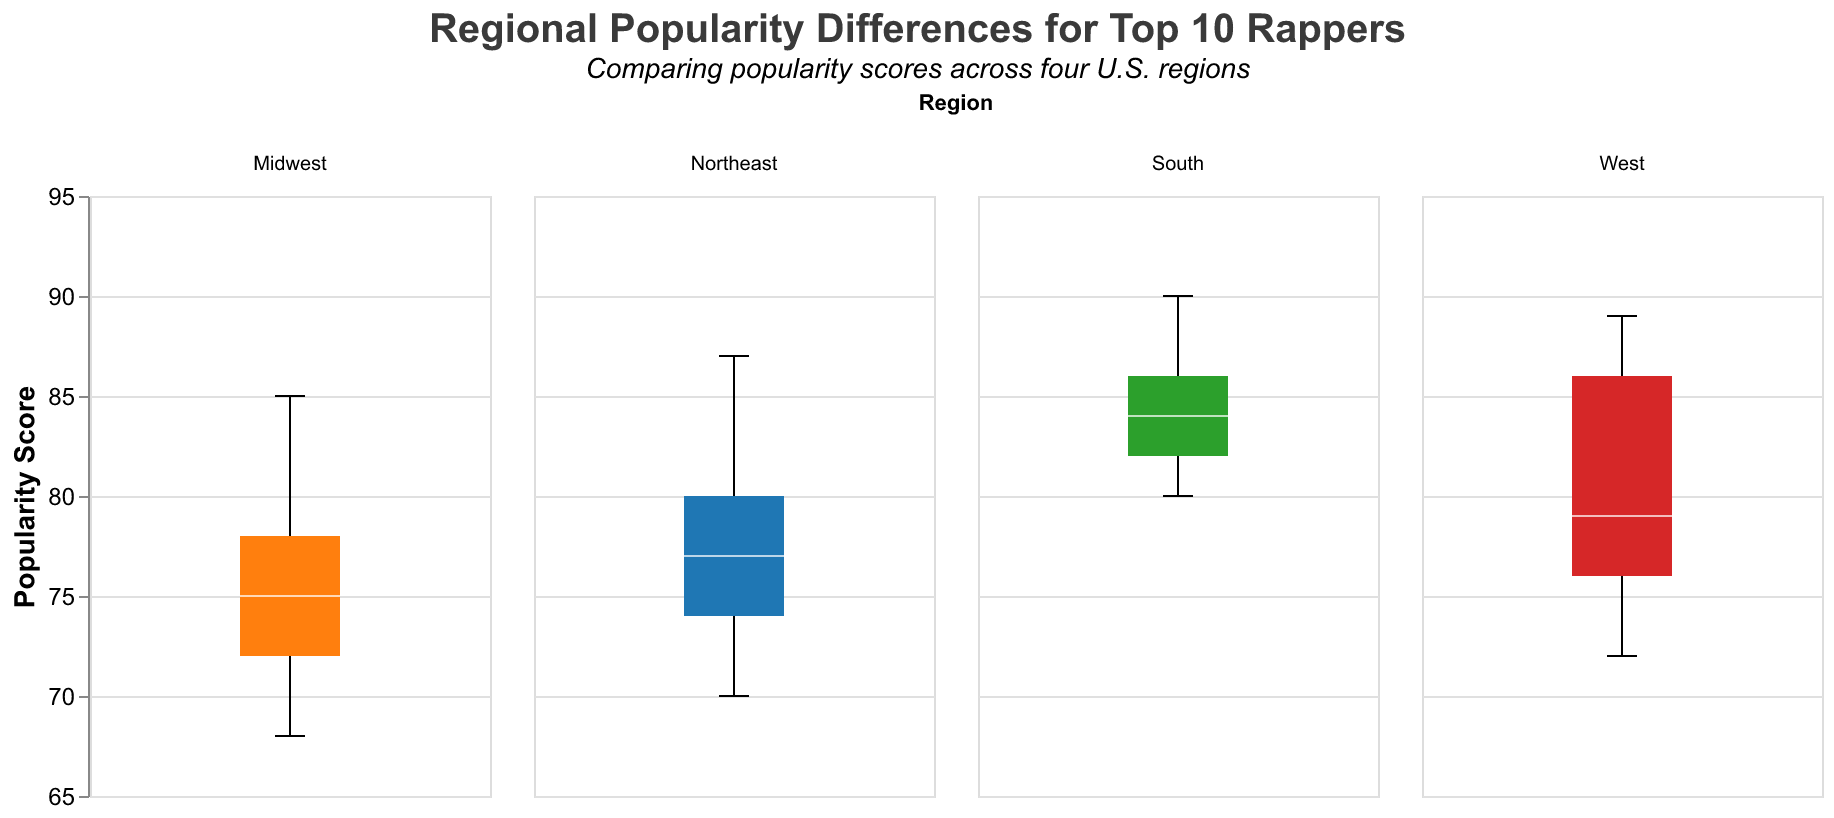How many regions are shown in the figure? The figure has separate subplots for each region. Observing the columns, there are four distinct regions displayed.
Answer: 4 Who is the most popular rapper in the South region? By examining the maximum values in the South region subplot, Drake has the highest popularity score of 90.
Answer: Drake Which rapper has the lowest popularity in the Midwest region? By looking at the minimum values in the Midwest region subplot, Future has the lowest popularity score of 68.
Answer: Future What is the median popularity score for J. Cole in all regions? To find the median, we observe the central tendency of J. Cole's popularity across all regions. The scores (82, 80, 83, 84) can be sorted as (80, 82, 83, 84). The median value is (82+83)/2 = 82.5.
Answer: 82.5 Which region has the highest interquartile range (IQR) for rapper popularity? The IQR is the difference between the third quartile (Q3) and the first quartile (Q1). Observing all subplots, the South region has the widest spread in rapper popularity.
Answer: South Are there any outliers in the popularity data for any rapper in the West region? Outliers would be represented as dots outside the whiskers in the box plots. There are no such dots in the West region subplot, indicating no outliers.
Answer: No Between the Northeast and the West, which region shows a higher median popularity score for Kendrick Lamar? Comparing the median lines for Kendrick Lamar: Northeast shows a median score of around 75, while West shows around 89.
Answer: West What is the average popularity score for Cardi B in all regions? To calculate the average, we sum Cardi B's popularity scores (77, 75, 80, 78) and divide by the count, which is 4. The total is 77+75+80+78 = 310, and the average is 310/4 = 77.5.
Answer: 77.5 Which region shows the smallest difference in popularity scores among rappers? Observing the range (difference between max and min) in each subplot, the Midwest has the smallest range, from 68 to 85, a difference of 17 points.
Answer: Midwest 